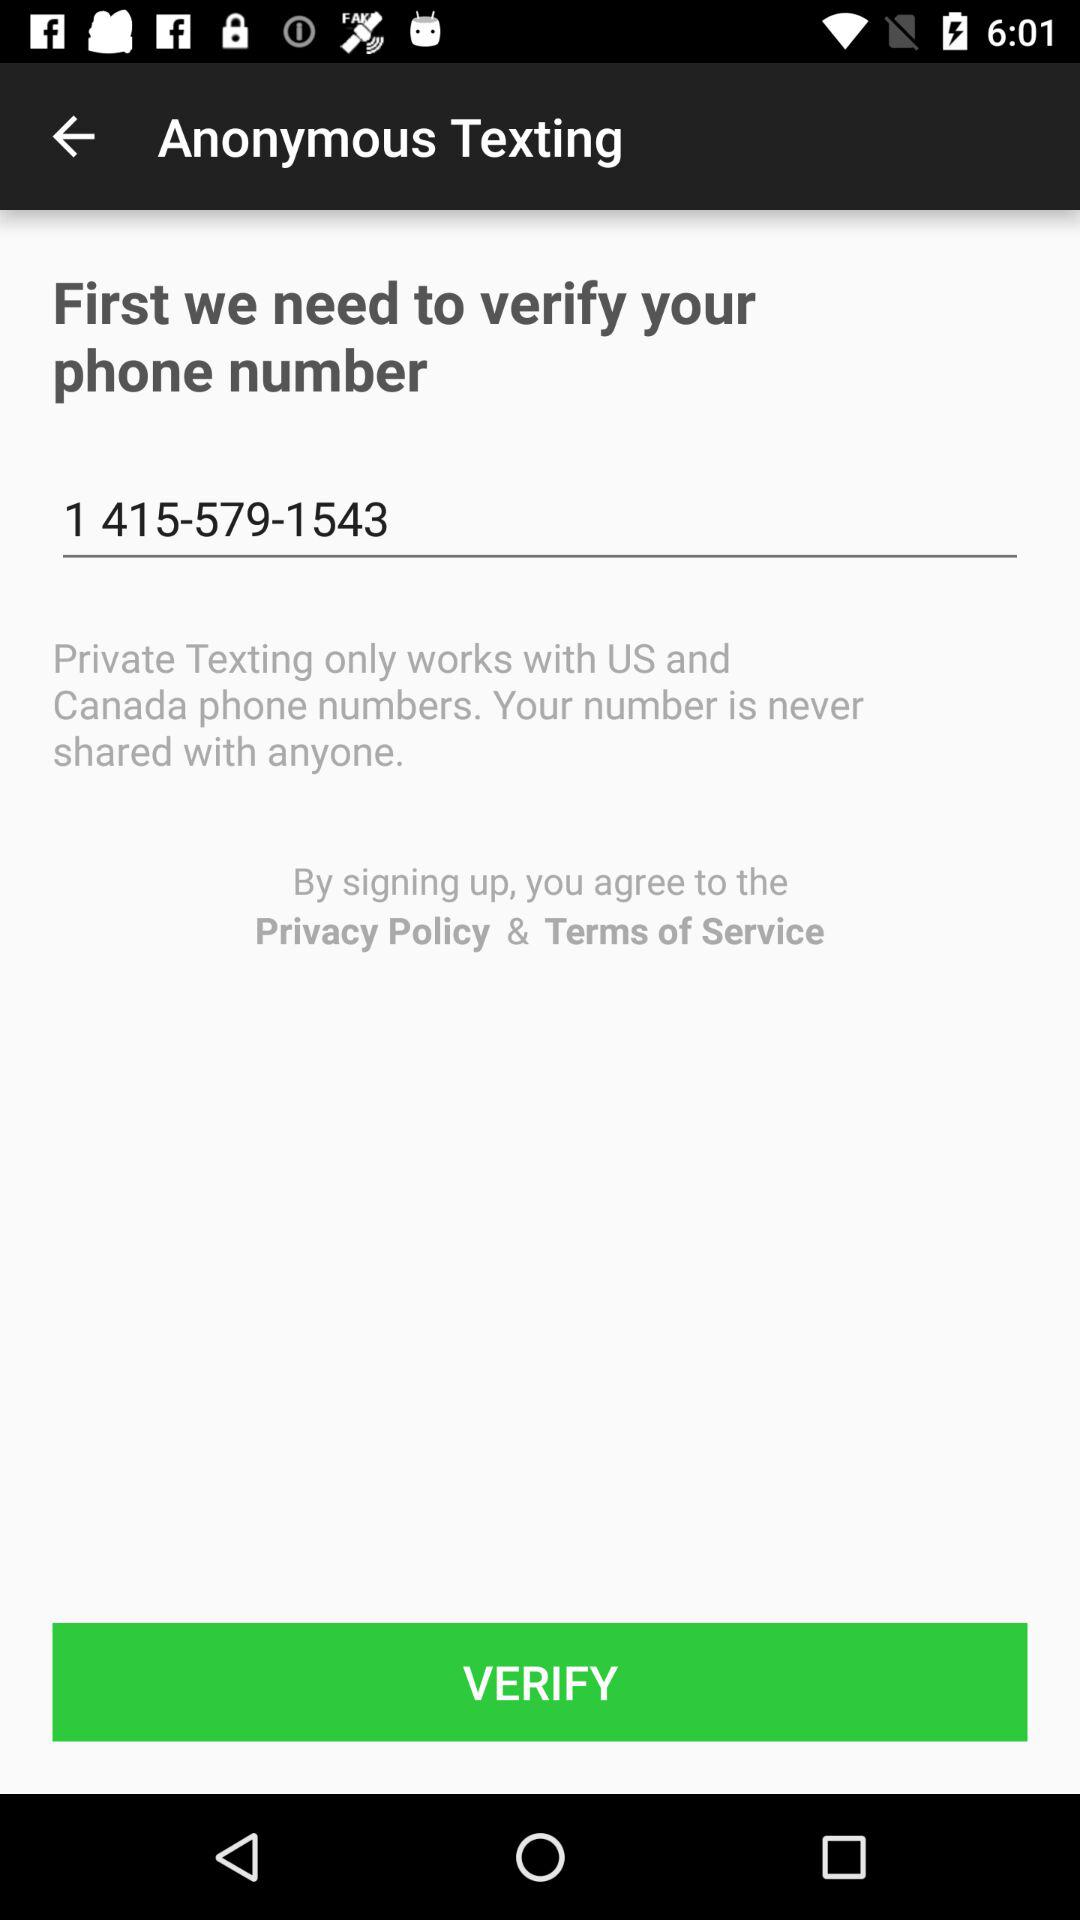Has the user agreed to the terms of service and privacy policy?
When the provided information is insufficient, respond with <no answer>. <no answer> 